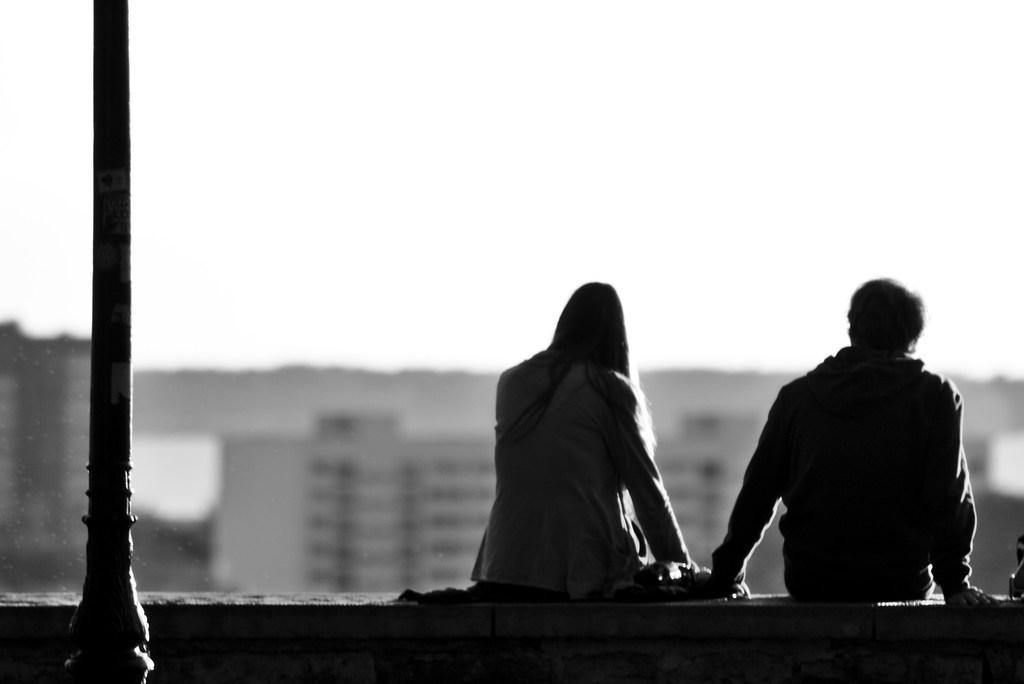Describe this image in one or two sentences. In this image I can see two people are sitting. In front I can see the pole and the image is in black and white. 